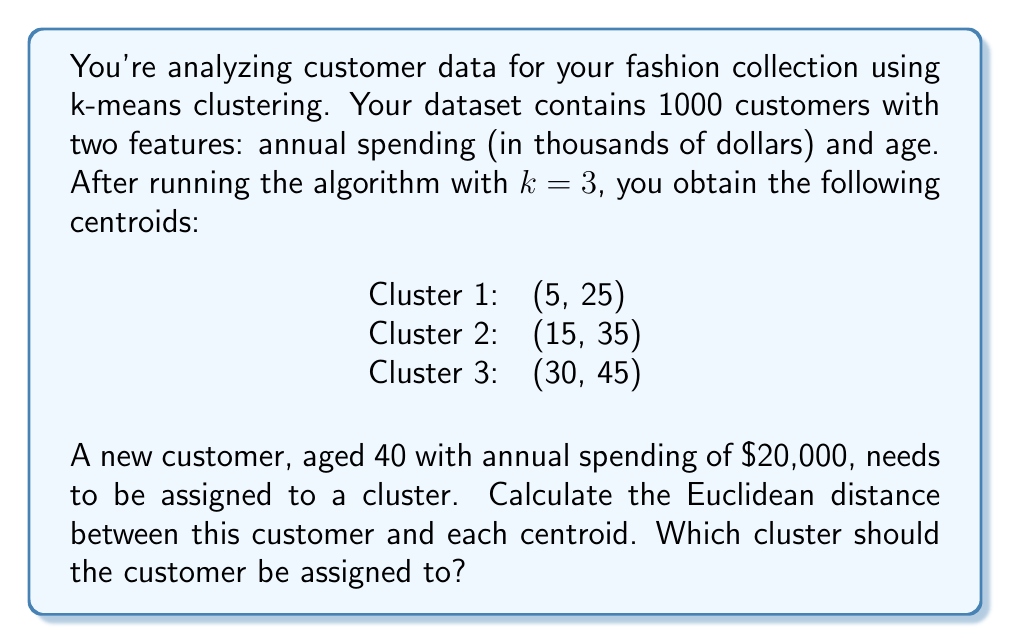Can you answer this question? To solve this problem, we need to follow these steps:

1. Understand the given data:
   - We have 3 cluster centroids: (5, 25), (15, 35), and (30, 45)
   - The new customer's data point is (20, 40)

2. Calculate the Euclidean distance between the new customer and each centroid using the formula:
   $$d = \sqrt{(x_2 - x_1)^2 + (y_2 - y_1)^2}$$
   where $(x_1, y_1)$ is the centroid and $(x_2, y_2)$ is the new customer's data point.

3. For Cluster 1:
   $$d_1 = \sqrt{(20 - 5)^2 + (40 - 25)^2} = \sqrt{225 + 225} = \sqrt{450} \approx 21.21$$

4. For Cluster 2:
   $$d_2 = \sqrt{(20 - 15)^2 + (40 - 35)^2} = \sqrt{25 + 25} = \sqrt{50} \approx 7.07$$

5. For Cluster 3:
   $$d_3 = \sqrt{(20 - 30)^2 + (40 - 45)^2} = \sqrt{100 + 25} = \sqrt{125} \approx 11.18$$

6. Compare the distances and assign the customer to the cluster with the smallest distance.

The smallest distance is $d_2 \approx 7.07$, corresponding to Cluster 2.
Answer: The customer should be assigned to Cluster 2, as it has the smallest Euclidean distance of approximately 7.07. 